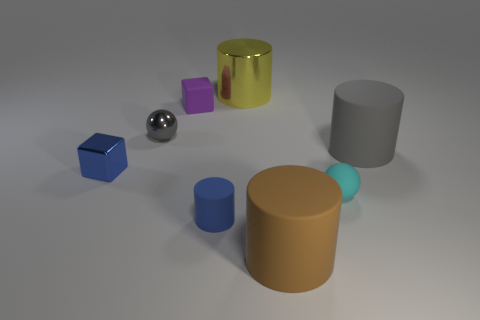What is the shape of the purple thing?
Your response must be concise. Cube. There is a sphere that is to the right of the small matte thing in front of the cyan matte ball; how big is it?
Give a very brief answer. Small. Are there an equal number of brown rubber things that are behind the blue rubber cylinder and big gray cylinders behind the large yellow cylinder?
Offer a terse response. Yes. The cylinder that is on the left side of the large brown matte thing and on the right side of the tiny blue cylinder is made of what material?
Offer a terse response. Metal. Do the matte sphere and the cylinder that is right of the tiny matte ball have the same size?
Your answer should be very brief. No. What number of other objects are the same color as the tiny metallic cube?
Make the answer very short. 1. Is the number of rubber cylinders on the right side of the yellow shiny cylinder greater than the number of yellow metal cylinders?
Offer a very short reply. Yes. There is a block that is to the left of the small ball that is to the left of the yellow metal cylinder behind the tiny metal ball; what color is it?
Give a very brief answer. Blue. Do the large brown thing and the purple cube have the same material?
Your response must be concise. Yes. Are there any gray rubber cylinders of the same size as the brown cylinder?
Provide a short and direct response. Yes. 